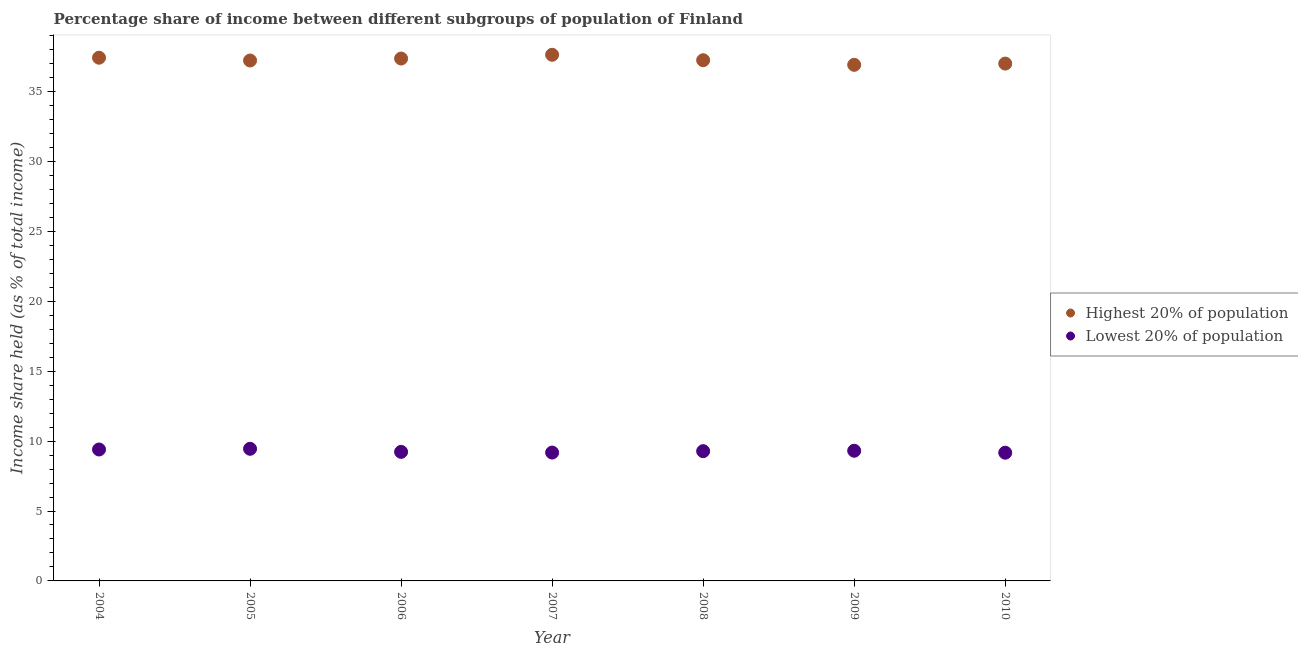Is the number of dotlines equal to the number of legend labels?
Provide a short and direct response. Yes. What is the income share held by lowest 20% of the population in 2008?
Your response must be concise. 9.28. Across all years, what is the maximum income share held by highest 20% of the population?
Your answer should be compact. 37.63. Across all years, what is the minimum income share held by highest 20% of the population?
Provide a succinct answer. 36.91. In which year was the income share held by highest 20% of the population minimum?
Provide a succinct answer. 2009. What is the total income share held by highest 20% of the population in the graph?
Offer a very short reply. 260.78. What is the difference between the income share held by lowest 20% of the population in 2004 and that in 2007?
Your response must be concise. 0.22. What is the difference between the income share held by lowest 20% of the population in 2006 and the income share held by highest 20% of the population in 2004?
Your answer should be compact. -28.19. What is the average income share held by lowest 20% of the population per year?
Keep it short and to the point. 9.29. In the year 2010, what is the difference between the income share held by lowest 20% of the population and income share held by highest 20% of the population?
Your response must be concise. -27.83. What is the ratio of the income share held by highest 20% of the population in 2006 to that in 2007?
Give a very brief answer. 0.99. Is the income share held by highest 20% of the population in 2005 less than that in 2007?
Provide a succinct answer. Yes. What is the difference between the highest and the second highest income share held by highest 20% of the population?
Your answer should be compact. 0.21. What is the difference between the highest and the lowest income share held by highest 20% of the population?
Your answer should be very brief. 0.72. Is the sum of the income share held by highest 20% of the population in 2004 and 2010 greater than the maximum income share held by lowest 20% of the population across all years?
Provide a short and direct response. Yes. Does the income share held by lowest 20% of the population monotonically increase over the years?
Give a very brief answer. No. Is the income share held by lowest 20% of the population strictly greater than the income share held by highest 20% of the population over the years?
Ensure brevity in your answer.  No. What is the difference between two consecutive major ticks on the Y-axis?
Provide a short and direct response. 5. Are the values on the major ticks of Y-axis written in scientific E-notation?
Offer a terse response. No. Does the graph contain any zero values?
Provide a short and direct response. No. Does the graph contain grids?
Offer a very short reply. No. Where does the legend appear in the graph?
Your response must be concise. Center right. How many legend labels are there?
Make the answer very short. 2. How are the legend labels stacked?
Your answer should be very brief. Vertical. What is the title of the graph?
Make the answer very short. Percentage share of income between different subgroups of population of Finland. Does "Not attending school" appear as one of the legend labels in the graph?
Provide a short and direct response. No. What is the label or title of the Y-axis?
Ensure brevity in your answer.  Income share held (as % of total income). What is the Income share held (as % of total income) in Highest 20% of population in 2004?
Your response must be concise. 37.42. What is the Income share held (as % of total income) of Highest 20% of population in 2005?
Your response must be concise. 37.22. What is the Income share held (as % of total income) in Lowest 20% of population in 2005?
Provide a succinct answer. 9.45. What is the Income share held (as % of total income) in Highest 20% of population in 2006?
Provide a short and direct response. 37.36. What is the Income share held (as % of total income) in Lowest 20% of population in 2006?
Offer a terse response. 9.23. What is the Income share held (as % of total income) of Highest 20% of population in 2007?
Your answer should be very brief. 37.63. What is the Income share held (as % of total income) of Lowest 20% of population in 2007?
Your answer should be compact. 9.18. What is the Income share held (as % of total income) in Highest 20% of population in 2008?
Make the answer very short. 37.24. What is the Income share held (as % of total income) in Lowest 20% of population in 2008?
Your response must be concise. 9.28. What is the Income share held (as % of total income) in Highest 20% of population in 2009?
Your response must be concise. 36.91. What is the Income share held (as % of total income) in Lowest 20% of population in 2009?
Ensure brevity in your answer.  9.31. What is the Income share held (as % of total income) in Highest 20% of population in 2010?
Your answer should be compact. 37. What is the Income share held (as % of total income) in Lowest 20% of population in 2010?
Your response must be concise. 9.17. Across all years, what is the maximum Income share held (as % of total income) in Highest 20% of population?
Your response must be concise. 37.63. Across all years, what is the maximum Income share held (as % of total income) in Lowest 20% of population?
Offer a terse response. 9.45. Across all years, what is the minimum Income share held (as % of total income) in Highest 20% of population?
Make the answer very short. 36.91. Across all years, what is the minimum Income share held (as % of total income) of Lowest 20% of population?
Your answer should be very brief. 9.17. What is the total Income share held (as % of total income) of Highest 20% of population in the graph?
Provide a succinct answer. 260.78. What is the total Income share held (as % of total income) of Lowest 20% of population in the graph?
Your answer should be compact. 65.02. What is the difference between the Income share held (as % of total income) in Highest 20% of population in 2004 and that in 2005?
Offer a very short reply. 0.2. What is the difference between the Income share held (as % of total income) in Lowest 20% of population in 2004 and that in 2005?
Your response must be concise. -0.05. What is the difference between the Income share held (as % of total income) of Highest 20% of population in 2004 and that in 2006?
Ensure brevity in your answer.  0.06. What is the difference between the Income share held (as % of total income) in Lowest 20% of population in 2004 and that in 2006?
Offer a very short reply. 0.17. What is the difference between the Income share held (as % of total income) in Highest 20% of population in 2004 and that in 2007?
Your response must be concise. -0.21. What is the difference between the Income share held (as % of total income) in Lowest 20% of population in 2004 and that in 2007?
Your answer should be very brief. 0.22. What is the difference between the Income share held (as % of total income) in Highest 20% of population in 2004 and that in 2008?
Offer a very short reply. 0.18. What is the difference between the Income share held (as % of total income) of Lowest 20% of population in 2004 and that in 2008?
Your answer should be compact. 0.12. What is the difference between the Income share held (as % of total income) of Highest 20% of population in 2004 and that in 2009?
Offer a very short reply. 0.51. What is the difference between the Income share held (as % of total income) of Lowest 20% of population in 2004 and that in 2009?
Give a very brief answer. 0.09. What is the difference between the Income share held (as % of total income) in Highest 20% of population in 2004 and that in 2010?
Your answer should be very brief. 0.42. What is the difference between the Income share held (as % of total income) in Lowest 20% of population in 2004 and that in 2010?
Offer a very short reply. 0.23. What is the difference between the Income share held (as % of total income) of Highest 20% of population in 2005 and that in 2006?
Your response must be concise. -0.14. What is the difference between the Income share held (as % of total income) in Lowest 20% of population in 2005 and that in 2006?
Ensure brevity in your answer.  0.22. What is the difference between the Income share held (as % of total income) in Highest 20% of population in 2005 and that in 2007?
Offer a terse response. -0.41. What is the difference between the Income share held (as % of total income) of Lowest 20% of population in 2005 and that in 2007?
Keep it short and to the point. 0.27. What is the difference between the Income share held (as % of total income) in Highest 20% of population in 2005 and that in 2008?
Offer a very short reply. -0.02. What is the difference between the Income share held (as % of total income) of Lowest 20% of population in 2005 and that in 2008?
Keep it short and to the point. 0.17. What is the difference between the Income share held (as % of total income) in Highest 20% of population in 2005 and that in 2009?
Provide a short and direct response. 0.31. What is the difference between the Income share held (as % of total income) in Lowest 20% of population in 2005 and that in 2009?
Provide a short and direct response. 0.14. What is the difference between the Income share held (as % of total income) in Highest 20% of population in 2005 and that in 2010?
Keep it short and to the point. 0.22. What is the difference between the Income share held (as % of total income) in Lowest 20% of population in 2005 and that in 2010?
Offer a very short reply. 0.28. What is the difference between the Income share held (as % of total income) of Highest 20% of population in 2006 and that in 2007?
Keep it short and to the point. -0.27. What is the difference between the Income share held (as % of total income) of Highest 20% of population in 2006 and that in 2008?
Make the answer very short. 0.12. What is the difference between the Income share held (as % of total income) of Highest 20% of population in 2006 and that in 2009?
Keep it short and to the point. 0.45. What is the difference between the Income share held (as % of total income) in Lowest 20% of population in 2006 and that in 2009?
Offer a very short reply. -0.08. What is the difference between the Income share held (as % of total income) of Highest 20% of population in 2006 and that in 2010?
Your answer should be compact. 0.36. What is the difference between the Income share held (as % of total income) of Lowest 20% of population in 2006 and that in 2010?
Keep it short and to the point. 0.06. What is the difference between the Income share held (as % of total income) in Highest 20% of population in 2007 and that in 2008?
Provide a short and direct response. 0.39. What is the difference between the Income share held (as % of total income) in Lowest 20% of population in 2007 and that in 2008?
Keep it short and to the point. -0.1. What is the difference between the Income share held (as % of total income) of Highest 20% of population in 2007 and that in 2009?
Keep it short and to the point. 0.72. What is the difference between the Income share held (as % of total income) of Lowest 20% of population in 2007 and that in 2009?
Your answer should be very brief. -0.13. What is the difference between the Income share held (as % of total income) of Highest 20% of population in 2007 and that in 2010?
Give a very brief answer. 0.63. What is the difference between the Income share held (as % of total income) of Highest 20% of population in 2008 and that in 2009?
Keep it short and to the point. 0.33. What is the difference between the Income share held (as % of total income) of Lowest 20% of population in 2008 and that in 2009?
Give a very brief answer. -0.03. What is the difference between the Income share held (as % of total income) of Highest 20% of population in 2008 and that in 2010?
Offer a terse response. 0.24. What is the difference between the Income share held (as % of total income) in Lowest 20% of population in 2008 and that in 2010?
Your answer should be compact. 0.11. What is the difference between the Income share held (as % of total income) of Highest 20% of population in 2009 and that in 2010?
Keep it short and to the point. -0.09. What is the difference between the Income share held (as % of total income) of Lowest 20% of population in 2009 and that in 2010?
Your response must be concise. 0.14. What is the difference between the Income share held (as % of total income) in Highest 20% of population in 2004 and the Income share held (as % of total income) in Lowest 20% of population in 2005?
Your answer should be compact. 27.97. What is the difference between the Income share held (as % of total income) of Highest 20% of population in 2004 and the Income share held (as % of total income) of Lowest 20% of population in 2006?
Your response must be concise. 28.19. What is the difference between the Income share held (as % of total income) in Highest 20% of population in 2004 and the Income share held (as % of total income) in Lowest 20% of population in 2007?
Your answer should be very brief. 28.24. What is the difference between the Income share held (as % of total income) in Highest 20% of population in 2004 and the Income share held (as % of total income) in Lowest 20% of population in 2008?
Provide a short and direct response. 28.14. What is the difference between the Income share held (as % of total income) in Highest 20% of population in 2004 and the Income share held (as % of total income) in Lowest 20% of population in 2009?
Give a very brief answer. 28.11. What is the difference between the Income share held (as % of total income) of Highest 20% of population in 2004 and the Income share held (as % of total income) of Lowest 20% of population in 2010?
Offer a terse response. 28.25. What is the difference between the Income share held (as % of total income) of Highest 20% of population in 2005 and the Income share held (as % of total income) of Lowest 20% of population in 2006?
Keep it short and to the point. 27.99. What is the difference between the Income share held (as % of total income) in Highest 20% of population in 2005 and the Income share held (as % of total income) in Lowest 20% of population in 2007?
Your answer should be compact. 28.04. What is the difference between the Income share held (as % of total income) of Highest 20% of population in 2005 and the Income share held (as % of total income) of Lowest 20% of population in 2008?
Your response must be concise. 27.94. What is the difference between the Income share held (as % of total income) in Highest 20% of population in 2005 and the Income share held (as % of total income) in Lowest 20% of population in 2009?
Offer a terse response. 27.91. What is the difference between the Income share held (as % of total income) in Highest 20% of population in 2005 and the Income share held (as % of total income) in Lowest 20% of population in 2010?
Provide a succinct answer. 28.05. What is the difference between the Income share held (as % of total income) of Highest 20% of population in 2006 and the Income share held (as % of total income) of Lowest 20% of population in 2007?
Offer a very short reply. 28.18. What is the difference between the Income share held (as % of total income) of Highest 20% of population in 2006 and the Income share held (as % of total income) of Lowest 20% of population in 2008?
Provide a succinct answer. 28.08. What is the difference between the Income share held (as % of total income) of Highest 20% of population in 2006 and the Income share held (as % of total income) of Lowest 20% of population in 2009?
Make the answer very short. 28.05. What is the difference between the Income share held (as % of total income) in Highest 20% of population in 2006 and the Income share held (as % of total income) in Lowest 20% of population in 2010?
Offer a very short reply. 28.19. What is the difference between the Income share held (as % of total income) of Highest 20% of population in 2007 and the Income share held (as % of total income) of Lowest 20% of population in 2008?
Your response must be concise. 28.35. What is the difference between the Income share held (as % of total income) in Highest 20% of population in 2007 and the Income share held (as % of total income) in Lowest 20% of population in 2009?
Your answer should be very brief. 28.32. What is the difference between the Income share held (as % of total income) of Highest 20% of population in 2007 and the Income share held (as % of total income) of Lowest 20% of population in 2010?
Your answer should be compact. 28.46. What is the difference between the Income share held (as % of total income) of Highest 20% of population in 2008 and the Income share held (as % of total income) of Lowest 20% of population in 2009?
Your response must be concise. 27.93. What is the difference between the Income share held (as % of total income) of Highest 20% of population in 2008 and the Income share held (as % of total income) of Lowest 20% of population in 2010?
Provide a short and direct response. 28.07. What is the difference between the Income share held (as % of total income) in Highest 20% of population in 2009 and the Income share held (as % of total income) in Lowest 20% of population in 2010?
Give a very brief answer. 27.74. What is the average Income share held (as % of total income) in Highest 20% of population per year?
Give a very brief answer. 37.25. What is the average Income share held (as % of total income) of Lowest 20% of population per year?
Your answer should be very brief. 9.29. In the year 2004, what is the difference between the Income share held (as % of total income) of Highest 20% of population and Income share held (as % of total income) of Lowest 20% of population?
Keep it short and to the point. 28.02. In the year 2005, what is the difference between the Income share held (as % of total income) of Highest 20% of population and Income share held (as % of total income) of Lowest 20% of population?
Your answer should be very brief. 27.77. In the year 2006, what is the difference between the Income share held (as % of total income) of Highest 20% of population and Income share held (as % of total income) of Lowest 20% of population?
Keep it short and to the point. 28.13. In the year 2007, what is the difference between the Income share held (as % of total income) in Highest 20% of population and Income share held (as % of total income) in Lowest 20% of population?
Your answer should be compact. 28.45. In the year 2008, what is the difference between the Income share held (as % of total income) of Highest 20% of population and Income share held (as % of total income) of Lowest 20% of population?
Provide a succinct answer. 27.96. In the year 2009, what is the difference between the Income share held (as % of total income) in Highest 20% of population and Income share held (as % of total income) in Lowest 20% of population?
Provide a succinct answer. 27.6. In the year 2010, what is the difference between the Income share held (as % of total income) of Highest 20% of population and Income share held (as % of total income) of Lowest 20% of population?
Keep it short and to the point. 27.83. What is the ratio of the Income share held (as % of total income) in Highest 20% of population in 2004 to that in 2005?
Keep it short and to the point. 1.01. What is the ratio of the Income share held (as % of total income) in Highest 20% of population in 2004 to that in 2006?
Keep it short and to the point. 1. What is the ratio of the Income share held (as % of total income) in Lowest 20% of population in 2004 to that in 2006?
Your response must be concise. 1.02. What is the ratio of the Income share held (as % of total income) of Lowest 20% of population in 2004 to that in 2007?
Provide a short and direct response. 1.02. What is the ratio of the Income share held (as % of total income) of Highest 20% of population in 2004 to that in 2008?
Your answer should be very brief. 1. What is the ratio of the Income share held (as % of total income) in Lowest 20% of population in 2004 to that in 2008?
Your answer should be compact. 1.01. What is the ratio of the Income share held (as % of total income) in Highest 20% of population in 2004 to that in 2009?
Make the answer very short. 1.01. What is the ratio of the Income share held (as % of total income) of Lowest 20% of population in 2004 to that in 2009?
Ensure brevity in your answer.  1.01. What is the ratio of the Income share held (as % of total income) in Highest 20% of population in 2004 to that in 2010?
Provide a short and direct response. 1.01. What is the ratio of the Income share held (as % of total income) in Lowest 20% of population in 2004 to that in 2010?
Offer a very short reply. 1.03. What is the ratio of the Income share held (as % of total income) in Highest 20% of population in 2005 to that in 2006?
Offer a very short reply. 1. What is the ratio of the Income share held (as % of total income) in Lowest 20% of population in 2005 to that in 2006?
Provide a short and direct response. 1.02. What is the ratio of the Income share held (as % of total income) in Highest 20% of population in 2005 to that in 2007?
Provide a short and direct response. 0.99. What is the ratio of the Income share held (as % of total income) in Lowest 20% of population in 2005 to that in 2007?
Keep it short and to the point. 1.03. What is the ratio of the Income share held (as % of total income) of Lowest 20% of population in 2005 to that in 2008?
Offer a very short reply. 1.02. What is the ratio of the Income share held (as % of total income) in Highest 20% of population in 2005 to that in 2009?
Your answer should be very brief. 1.01. What is the ratio of the Income share held (as % of total income) in Highest 20% of population in 2005 to that in 2010?
Provide a succinct answer. 1.01. What is the ratio of the Income share held (as % of total income) of Lowest 20% of population in 2005 to that in 2010?
Your answer should be very brief. 1.03. What is the ratio of the Income share held (as % of total income) of Highest 20% of population in 2006 to that in 2007?
Make the answer very short. 0.99. What is the ratio of the Income share held (as % of total income) of Lowest 20% of population in 2006 to that in 2007?
Provide a short and direct response. 1.01. What is the ratio of the Income share held (as % of total income) of Highest 20% of population in 2006 to that in 2008?
Ensure brevity in your answer.  1. What is the ratio of the Income share held (as % of total income) in Lowest 20% of population in 2006 to that in 2008?
Ensure brevity in your answer.  0.99. What is the ratio of the Income share held (as % of total income) in Highest 20% of population in 2006 to that in 2009?
Provide a succinct answer. 1.01. What is the ratio of the Income share held (as % of total income) in Lowest 20% of population in 2006 to that in 2009?
Provide a short and direct response. 0.99. What is the ratio of the Income share held (as % of total income) in Highest 20% of population in 2006 to that in 2010?
Make the answer very short. 1.01. What is the ratio of the Income share held (as % of total income) of Lowest 20% of population in 2006 to that in 2010?
Provide a succinct answer. 1.01. What is the ratio of the Income share held (as % of total income) in Highest 20% of population in 2007 to that in 2008?
Offer a terse response. 1.01. What is the ratio of the Income share held (as % of total income) in Highest 20% of population in 2007 to that in 2009?
Your response must be concise. 1.02. What is the ratio of the Income share held (as % of total income) in Highest 20% of population in 2008 to that in 2009?
Give a very brief answer. 1.01. What is the ratio of the Income share held (as % of total income) of Lowest 20% of population in 2008 to that in 2009?
Provide a short and direct response. 1. What is the ratio of the Income share held (as % of total income) of Lowest 20% of population in 2009 to that in 2010?
Provide a succinct answer. 1.02. What is the difference between the highest and the second highest Income share held (as % of total income) in Highest 20% of population?
Offer a terse response. 0.21. What is the difference between the highest and the second highest Income share held (as % of total income) in Lowest 20% of population?
Offer a very short reply. 0.05. What is the difference between the highest and the lowest Income share held (as % of total income) in Highest 20% of population?
Offer a terse response. 0.72. What is the difference between the highest and the lowest Income share held (as % of total income) of Lowest 20% of population?
Provide a short and direct response. 0.28. 